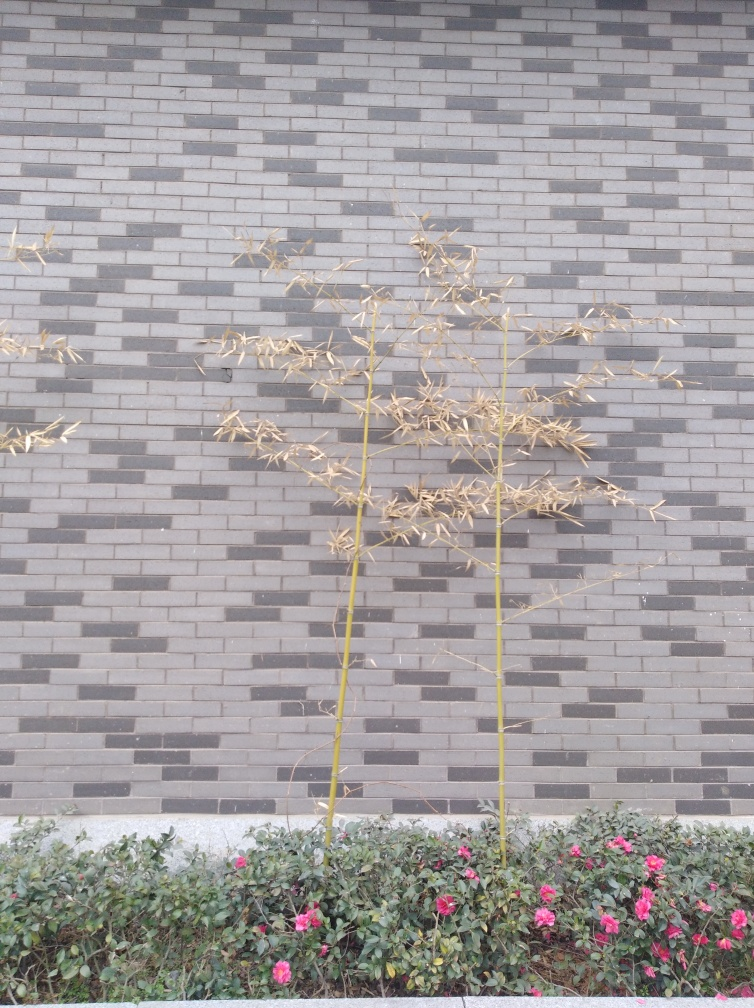Is the texture detail of the grass lost? While there isn't any grass visible in the image, the texture details of the plants and the surface behind them are preserved. One can observe the clear contrast between the rough-textured brick wall pattern and the delicate dried plant, as well as the vibrant pink flowers in the foreground. 